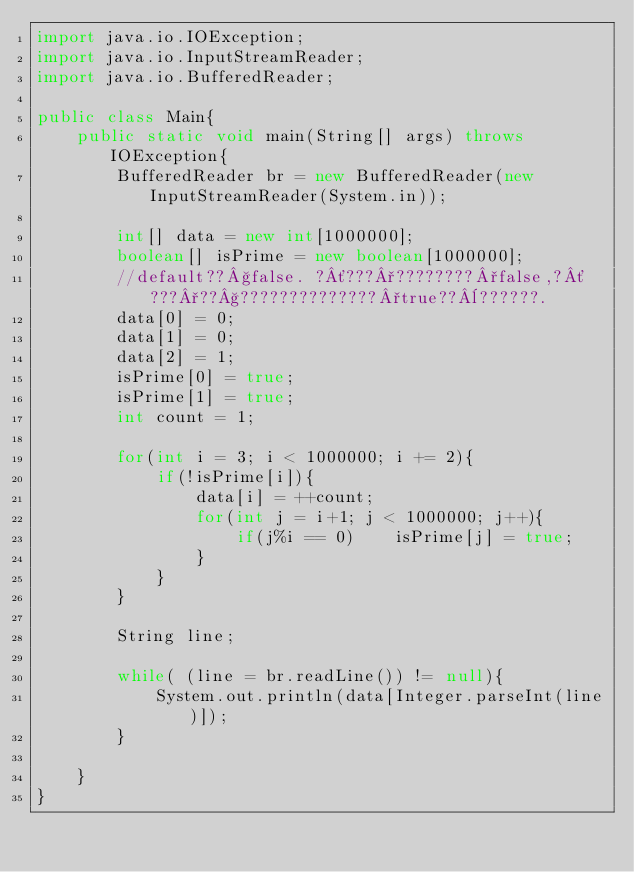Convert code to text. <code><loc_0><loc_0><loc_500><loc_500><_Java_>import java.io.IOException;
import java.io.InputStreamReader;
import java.io.BufferedReader;

public class Main{
    public static void main(String[] args) throws IOException{
        BufferedReader br = new BufferedReader(new InputStreamReader(System.in));

        int[] data = new int[1000000];
        boolean[] isPrime = new boolean[1000000];
        //default??§false. ?´???°????????°false,?´???°??§??????????????°true??¨??????.
        data[0] = 0;
        data[1] = 0;
        data[2] = 1;
        isPrime[0] = true;
        isPrime[1] = true;
        int count = 1;
        
        for(int i = 3; i < 1000000; i += 2){
            if(!isPrime[i]){
                data[i] = ++count;
                for(int j = i+1; j < 1000000; j++){
                    if(j%i == 0)    isPrime[j] = true;
                }
            }
        }

        String line;

        while( (line = br.readLine()) != null){
            System.out.println(data[Integer.parseInt(line)]);
        }
        
    }
}</code> 